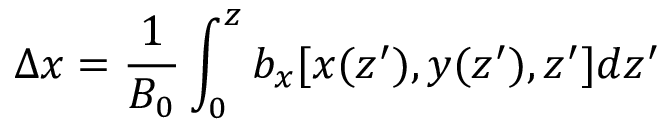<formula> <loc_0><loc_0><loc_500><loc_500>\Delta x = \frac { 1 } { B _ { 0 } } \int _ { 0 } ^ { z } b _ { x } [ x ( { z } ^ { \prime } ) , y ( { z } ^ { \prime } ) , z ^ { \prime } ] d { z } ^ { \prime }</formula> 